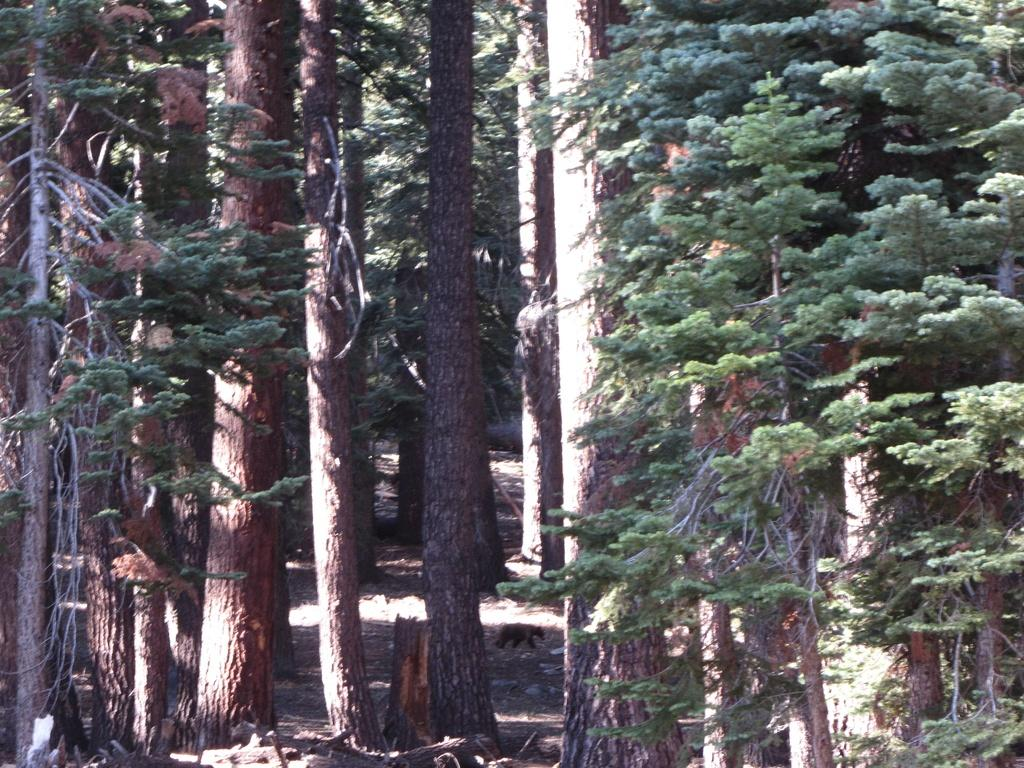What type of vegetation is in the middle of the image? There are trees in the middle of the image. What animal can be seen at the bottom of the image? There is a bear at the bottom of the image. What type of sport is being played by the bear in the image? There is no sport being played in the image; it only features a bear and trees. How many potatoes can be seen in the image? There are no potatoes present in the image. 